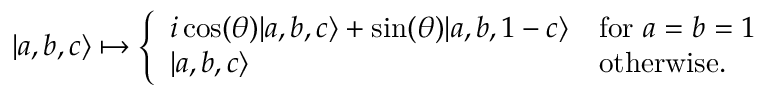<formula> <loc_0><loc_0><loc_500><loc_500>| a , b , c \rangle \mapsto { \left \{ \begin{array} { l l } { i \cos ( \theta ) | a , b , c \rangle + \sin ( \theta ) | a , b , 1 - c \rangle } & { { f o r } a = b = 1 } \\ { | a , b , c \rangle } & { o t h e r w i s e . } \end{array} }</formula> 